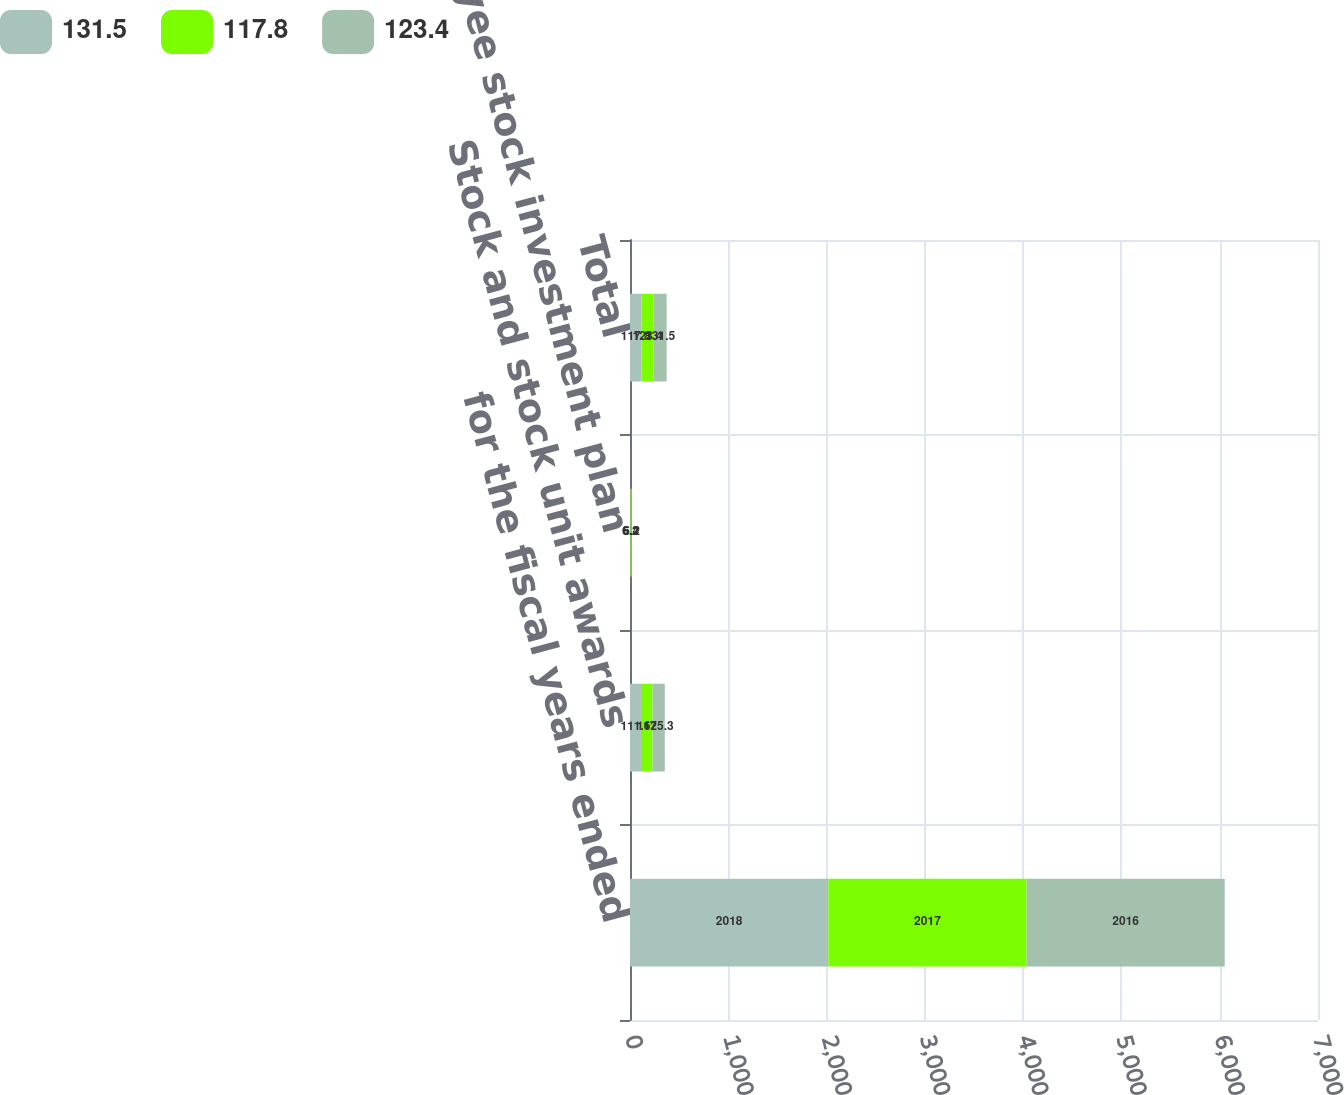Convert chart to OTSL. <chart><loc_0><loc_0><loc_500><loc_500><stacked_bar_chart><ecel><fcel>for the fiscal years ended<fcel>Stock and stock unit awards<fcel>Employee stock investment plan<fcel>Total<nl><fcel>131.5<fcel>2018<fcel>111.6<fcel>6.2<fcel>117.8<nl><fcel>117.8<fcel>2017<fcel>117<fcel>6.4<fcel>123.4<nl><fcel>123.4<fcel>2016<fcel>125.3<fcel>6.2<fcel>131.5<nl></chart> 